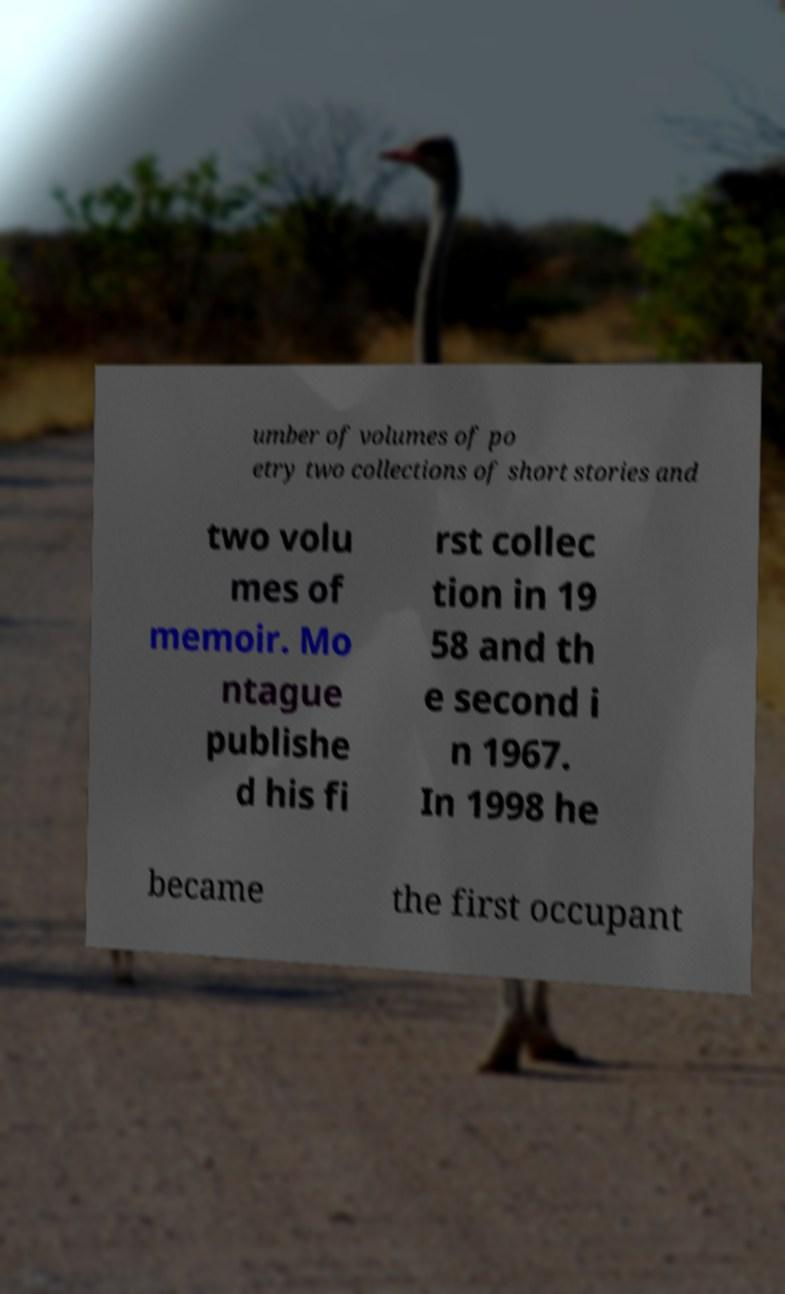Please read and relay the text visible in this image. What does it say? umber of volumes of po etry two collections of short stories and two volu mes of memoir. Mo ntague publishe d his fi rst collec tion in 19 58 and th e second i n 1967. In 1998 he became the first occupant 